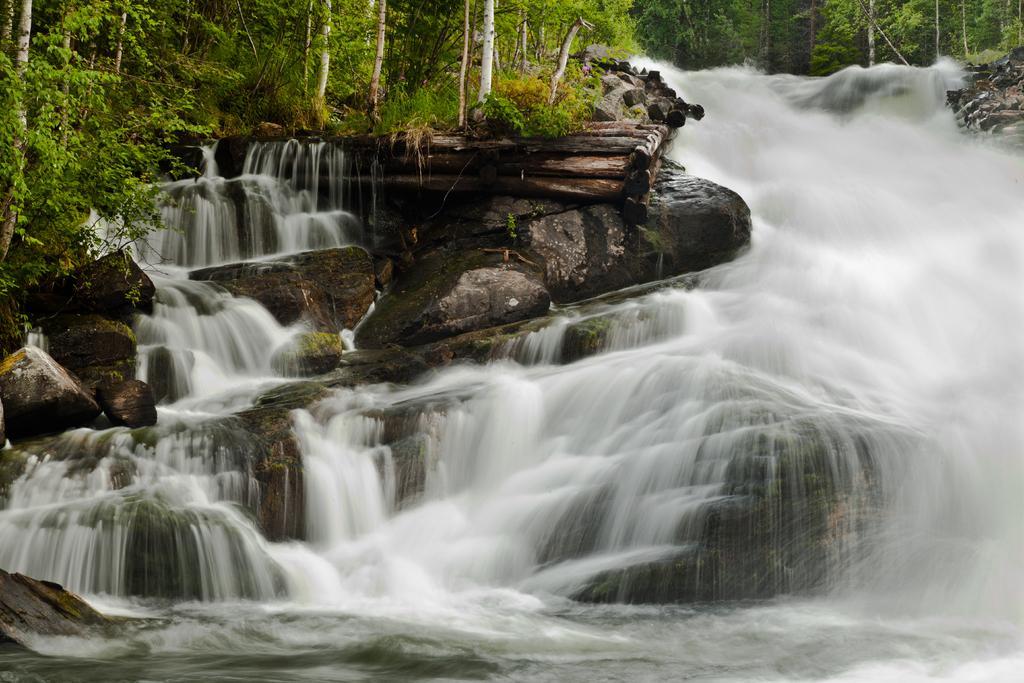In one or two sentences, can you explain what this image depicts? In the picture I can see water falls and there are few rocks and trees in the background. 